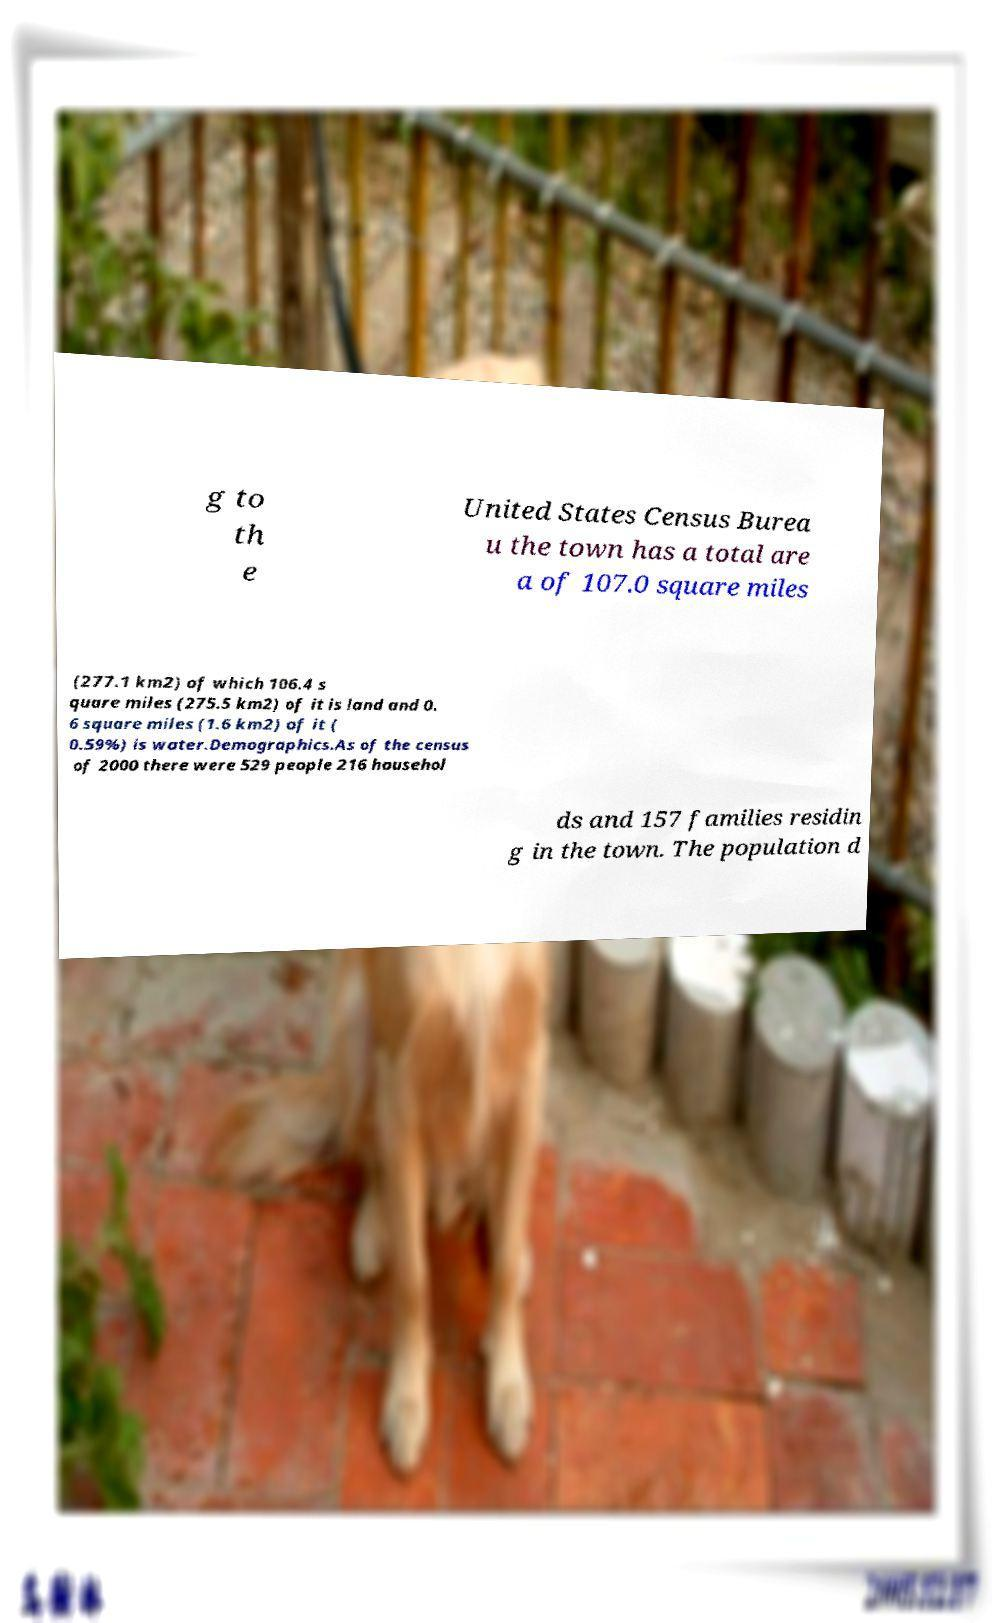Could you assist in decoding the text presented in this image and type it out clearly? g to th e United States Census Burea u the town has a total are a of 107.0 square miles (277.1 km2) of which 106.4 s quare miles (275.5 km2) of it is land and 0. 6 square miles (1.6 km2) of it ( 0.59%) is water.Demographics.As of the census of 2000 there were 529 people 216 househol ds and 157 families residin g in the town. The population d 